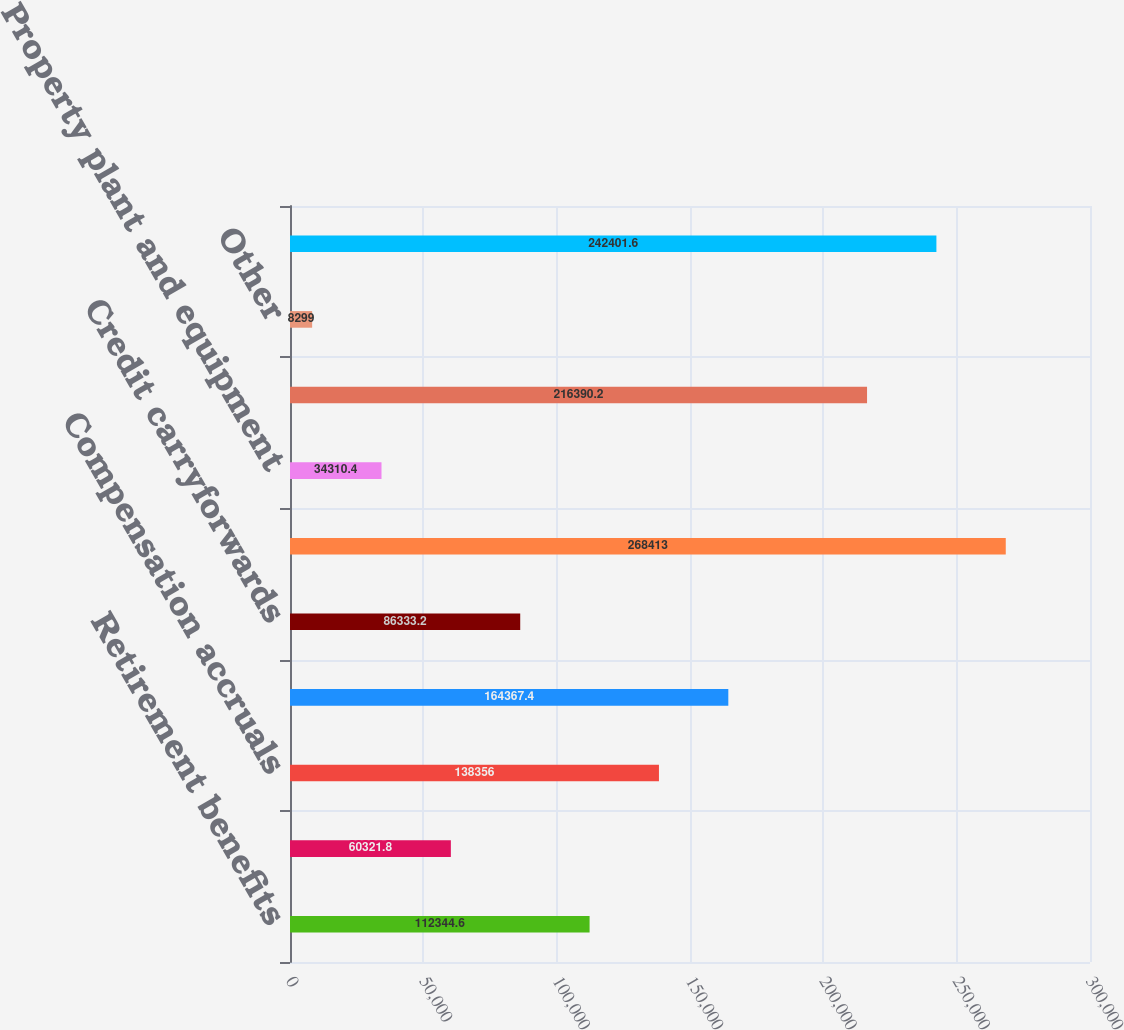<chart> <loc_0><loc_0><loc_500><loc_500><bar_chart><fcel>Retirement benefits<fcel>Net operating loss<fcel>Compensation accruals<fcel>Inventories<fcel>Credit carryforwards<fcel>Net deferred tax assets<fcel>Property plant and equipment<fcel>Goodwill and intangibles<fcel>Other<fcel>Total deferred tax liabilities<nl><fcel>112345<fcel>60321.8<fcel>138356<fcel>164367<fcel>86333.2<fcel>268413<fcel>34310.4<fcel>216390<fcel>8299<fcel>242402<nl></chart> 